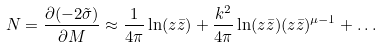Convert formula to latex. <formula><loc_0><loc_0><loc_500><loc_500>N = \frac { \partial ( - 2 \tilde { \sigma } ) } { \partial M } \approx \frac { 1 } { 4 \pi } \ln ( z \bar { z } ) + \frac { k ^ { 2 } } { 4 \pi } \ln ( z \bar { z } ) ( z \bar { z } ) ^ { \mu - 1 } + \dots</formula> 